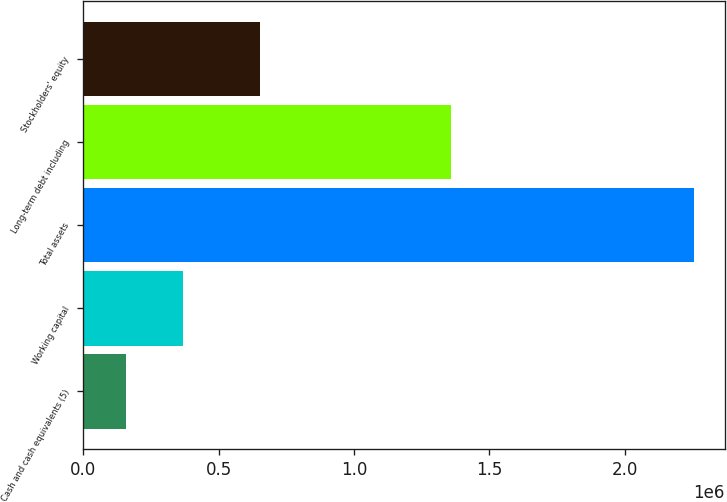Convert chart. <chart><loc_0><loc_0><loc_500><loc_500><bar_chart><fcel>Cash and cash equivalents (5)<fcel>Working capital<fcel>Total assets<fcel>Long-term debt including<fcel>Stockholders' equity<nl><fcel>159062<fcel>368738<fcel>2.25582e+06<fcel>1.35723e+06<fcel>653900<nl></chart> 